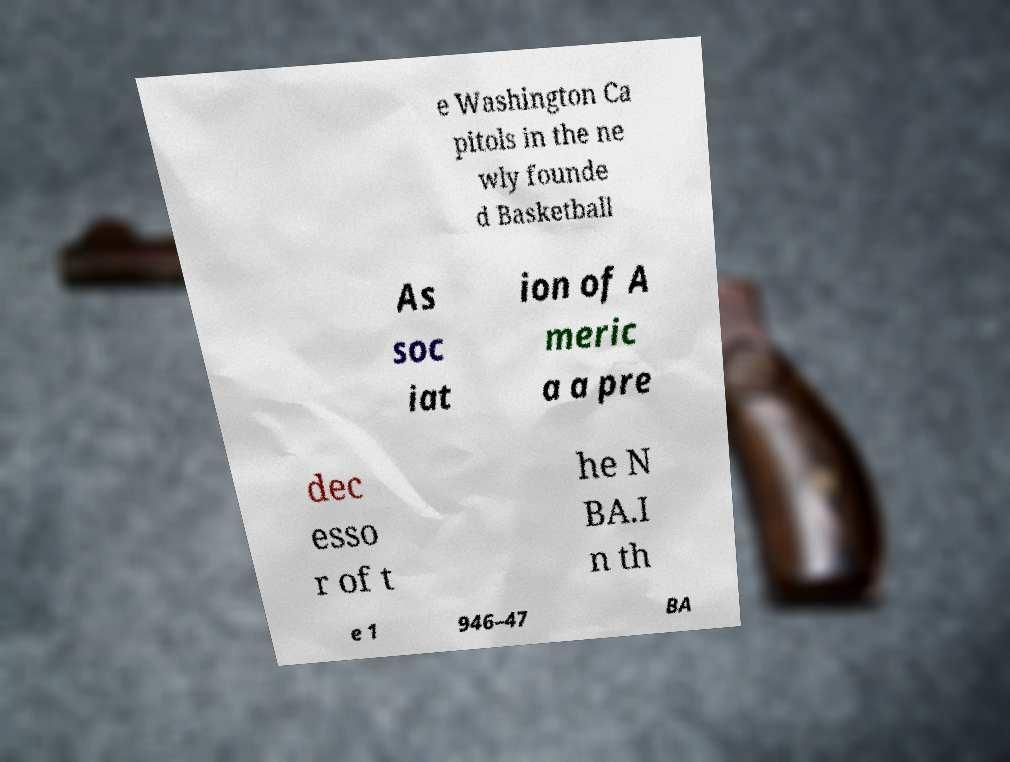I need the written content from this picture converted into text. Can you do that? e Washington Ca pitols in the ne wly founde d Basketball As soc iat ion of A meric a a pre dec esso r of t he N BA.I n th e 1 946–47 BA 